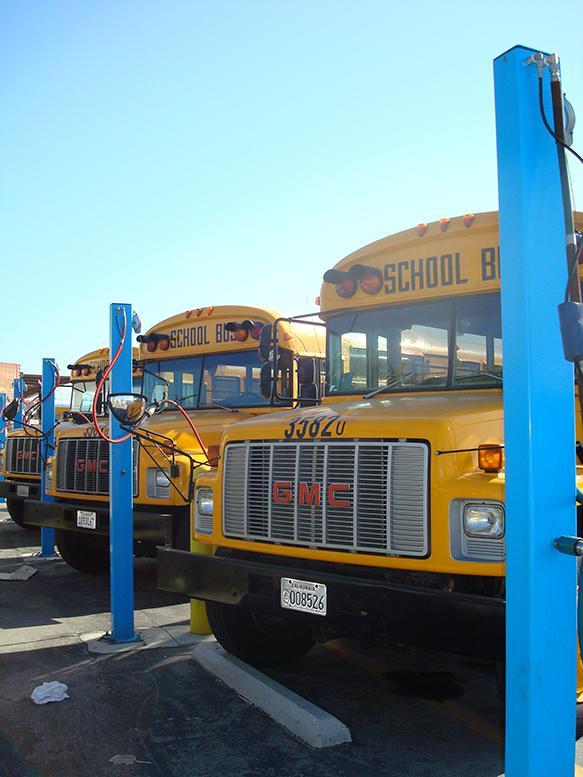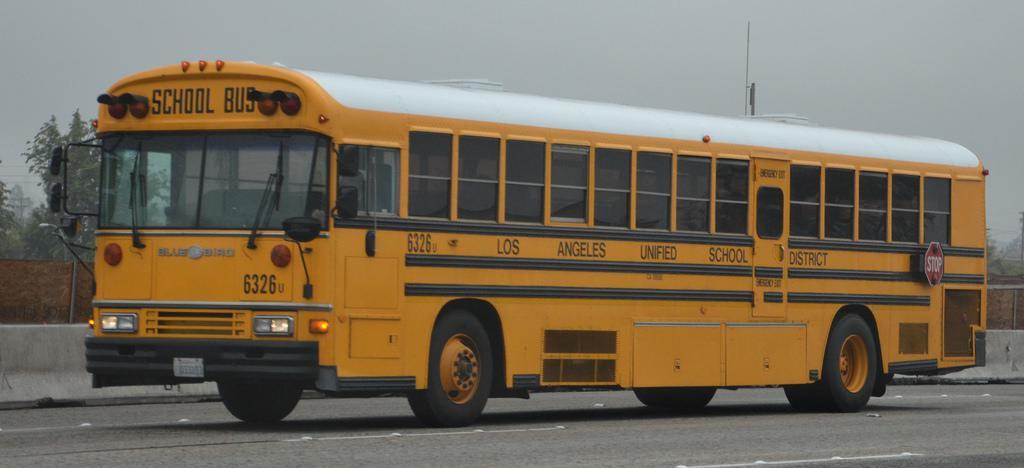The first image is the image on the left, the second image is the image on the right. Examine the images to the left and right. Is the description "There are more buses in the image on the right." accurate? Answer yes or no. No. The first image is the image on the left, the second image is the image on the right. Examine the images to the left and right. Is the description "One image shows the back of three or more school buses parked at an angle, while a second image shows the front of one bus." accurate? Answer yes or no. No. 